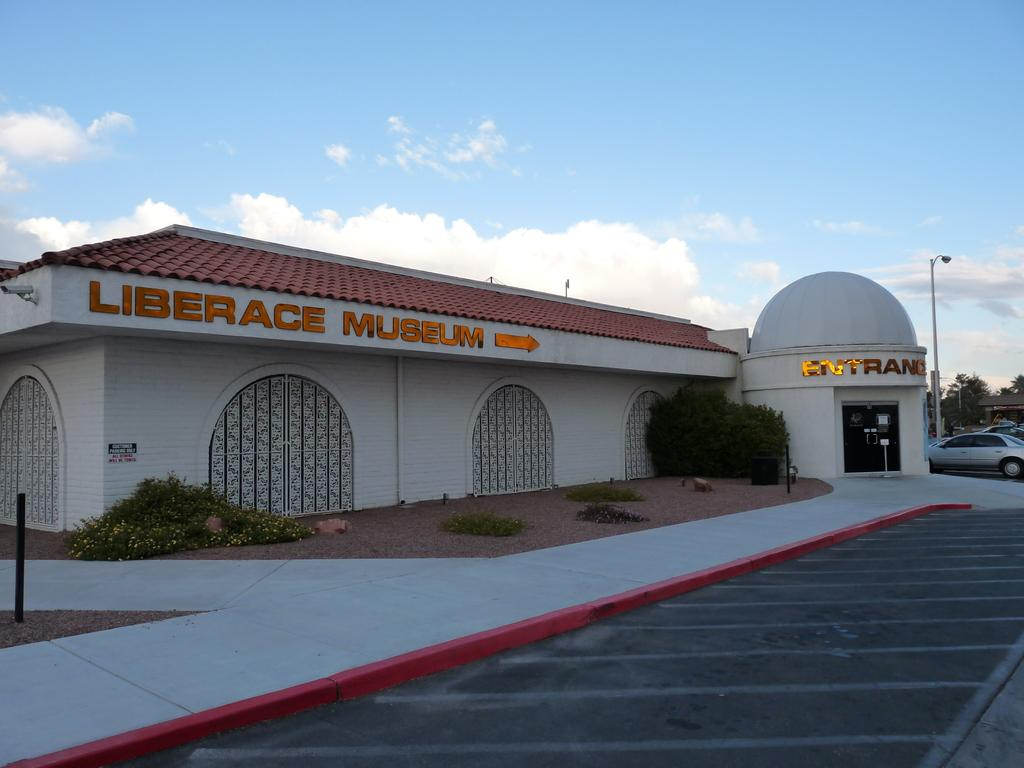What is the main subject in the center of the image? There is a building in the center of the image. What type of vegetation can be seen in the image? There are bushes visible in the image. What is located at the bottom of the image? There is a road at the bottom of the image. What type of vehicles are present on the road? Cars are present on the road. What can be seen in the background of the image? There are poles, trees, and the sky visible in the background of the image. Can you tell me how many attempts the wren made to fly in the image? There is no wren present in the image, so it is not possible to determine how many attempts it made to fly. 